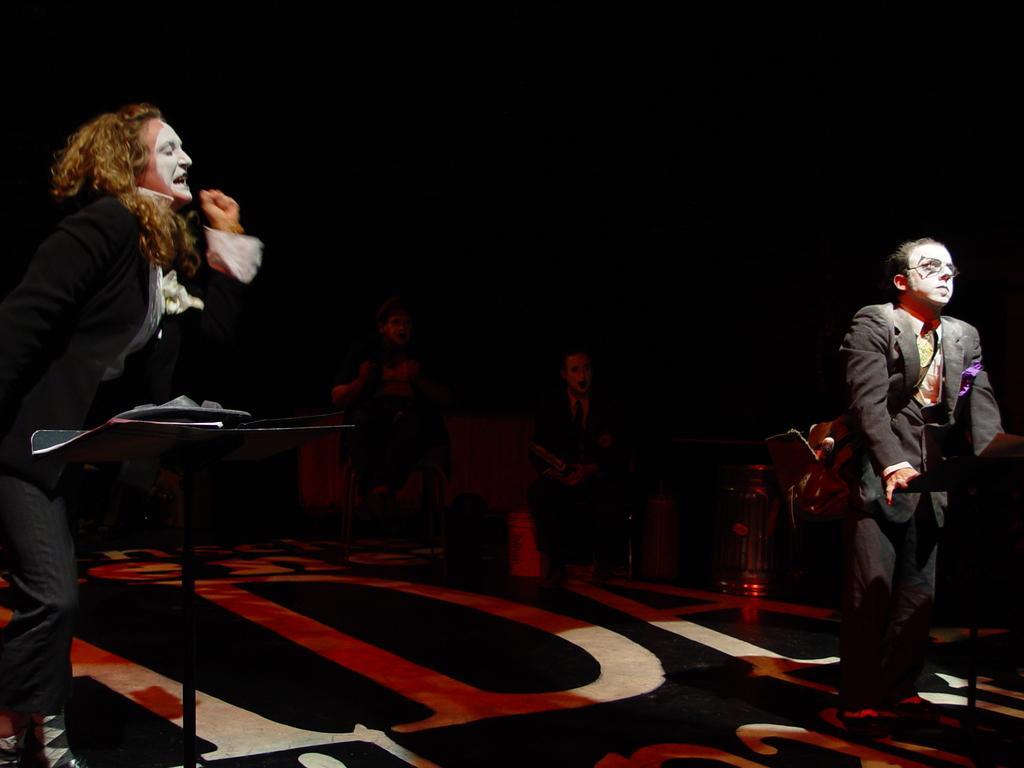Describe this image in one or two sentences. There are two persons on the sides. On the left side there is a stand. In the back there are two persons sitting. Also there are some items. In the background it is dark. 